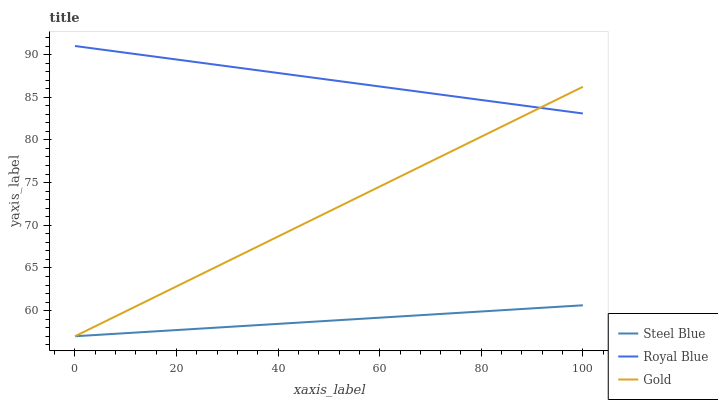Does Steel Blue have the minimum area under the curve?
Answer yes or no. Yes. Does Royal Blue have the maximum area under the curve?
Answer yes or no. Yes. Does Gold have the minimum area under the curve?
Answer yes or no. No. Does Gold have the maximum area under the curve?
Answer yes or no. No. Is Steel Blue the smoothest?
Answer yes or no. Yes. Is Royal Blue the roughest?
Answer yes or no. Yes. Is Gold the smoothest?
Answer yes or no. No. Is Gold the roughest?
Answer yes or no. No. Does Steel Blue have the lowest value?
Answer yes or no. Yes. Does Royal Blue have the highest value?
Answer yes or no. Yes. Does Gold have the highest value?
Answer yes or no. No. Is Steel Blue less than Royal Blue?
Answer yes or no. Yes. Is Royal Blue greater than Steel Blue?
Answer yes or no. Yes. Does Steel Blue intersect Gold?
Answer yes or no. Yes. Is Steel Blue less than Gold?
Answer yes or no. No. Is Steel Blue greater than Gold?
Answer yes or no. No. Does Steel Blue intersect Royal Blue?
Answer yes or no. No. 